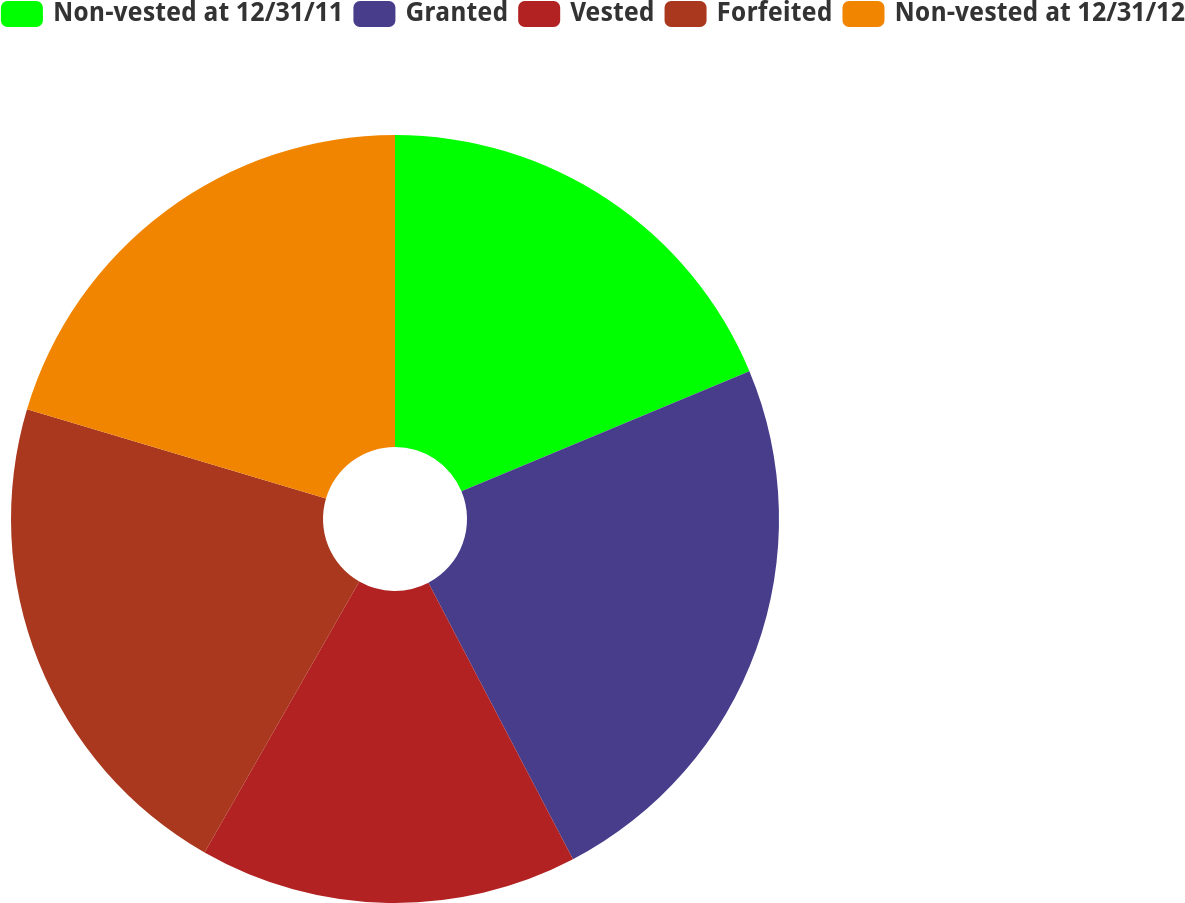Convert chart. <chart><loc_0><loc_0><loc_500><loc_500><pie_chart><fcel>Non-vested at 12/31/11<fcel>Granted<fcel>Vested<fcel>Forfeited<fcel>Non-vested at 12/31/12<nl><fcel>18.71%<fcel>23.62%<fcel>15.93%<fcel>21.35%<fcel>20.39%<nl></chart> 